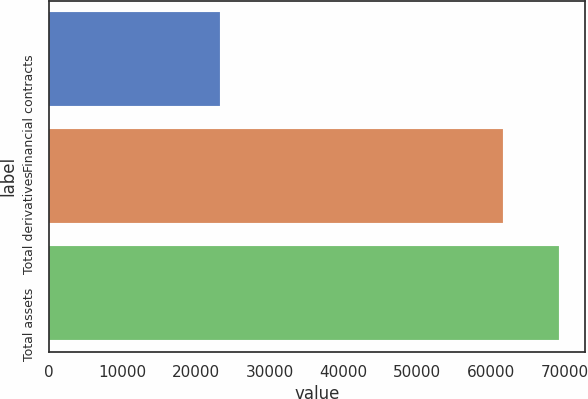<chart> <loc_0><loc_0><loc_500><loc_500><bar_chart><fcel>Financial contracts<fcel>Total derivatives<fcel>Total assets<nl><fcel>23164<fcel>61604<fcel>69302<nl></chart> 